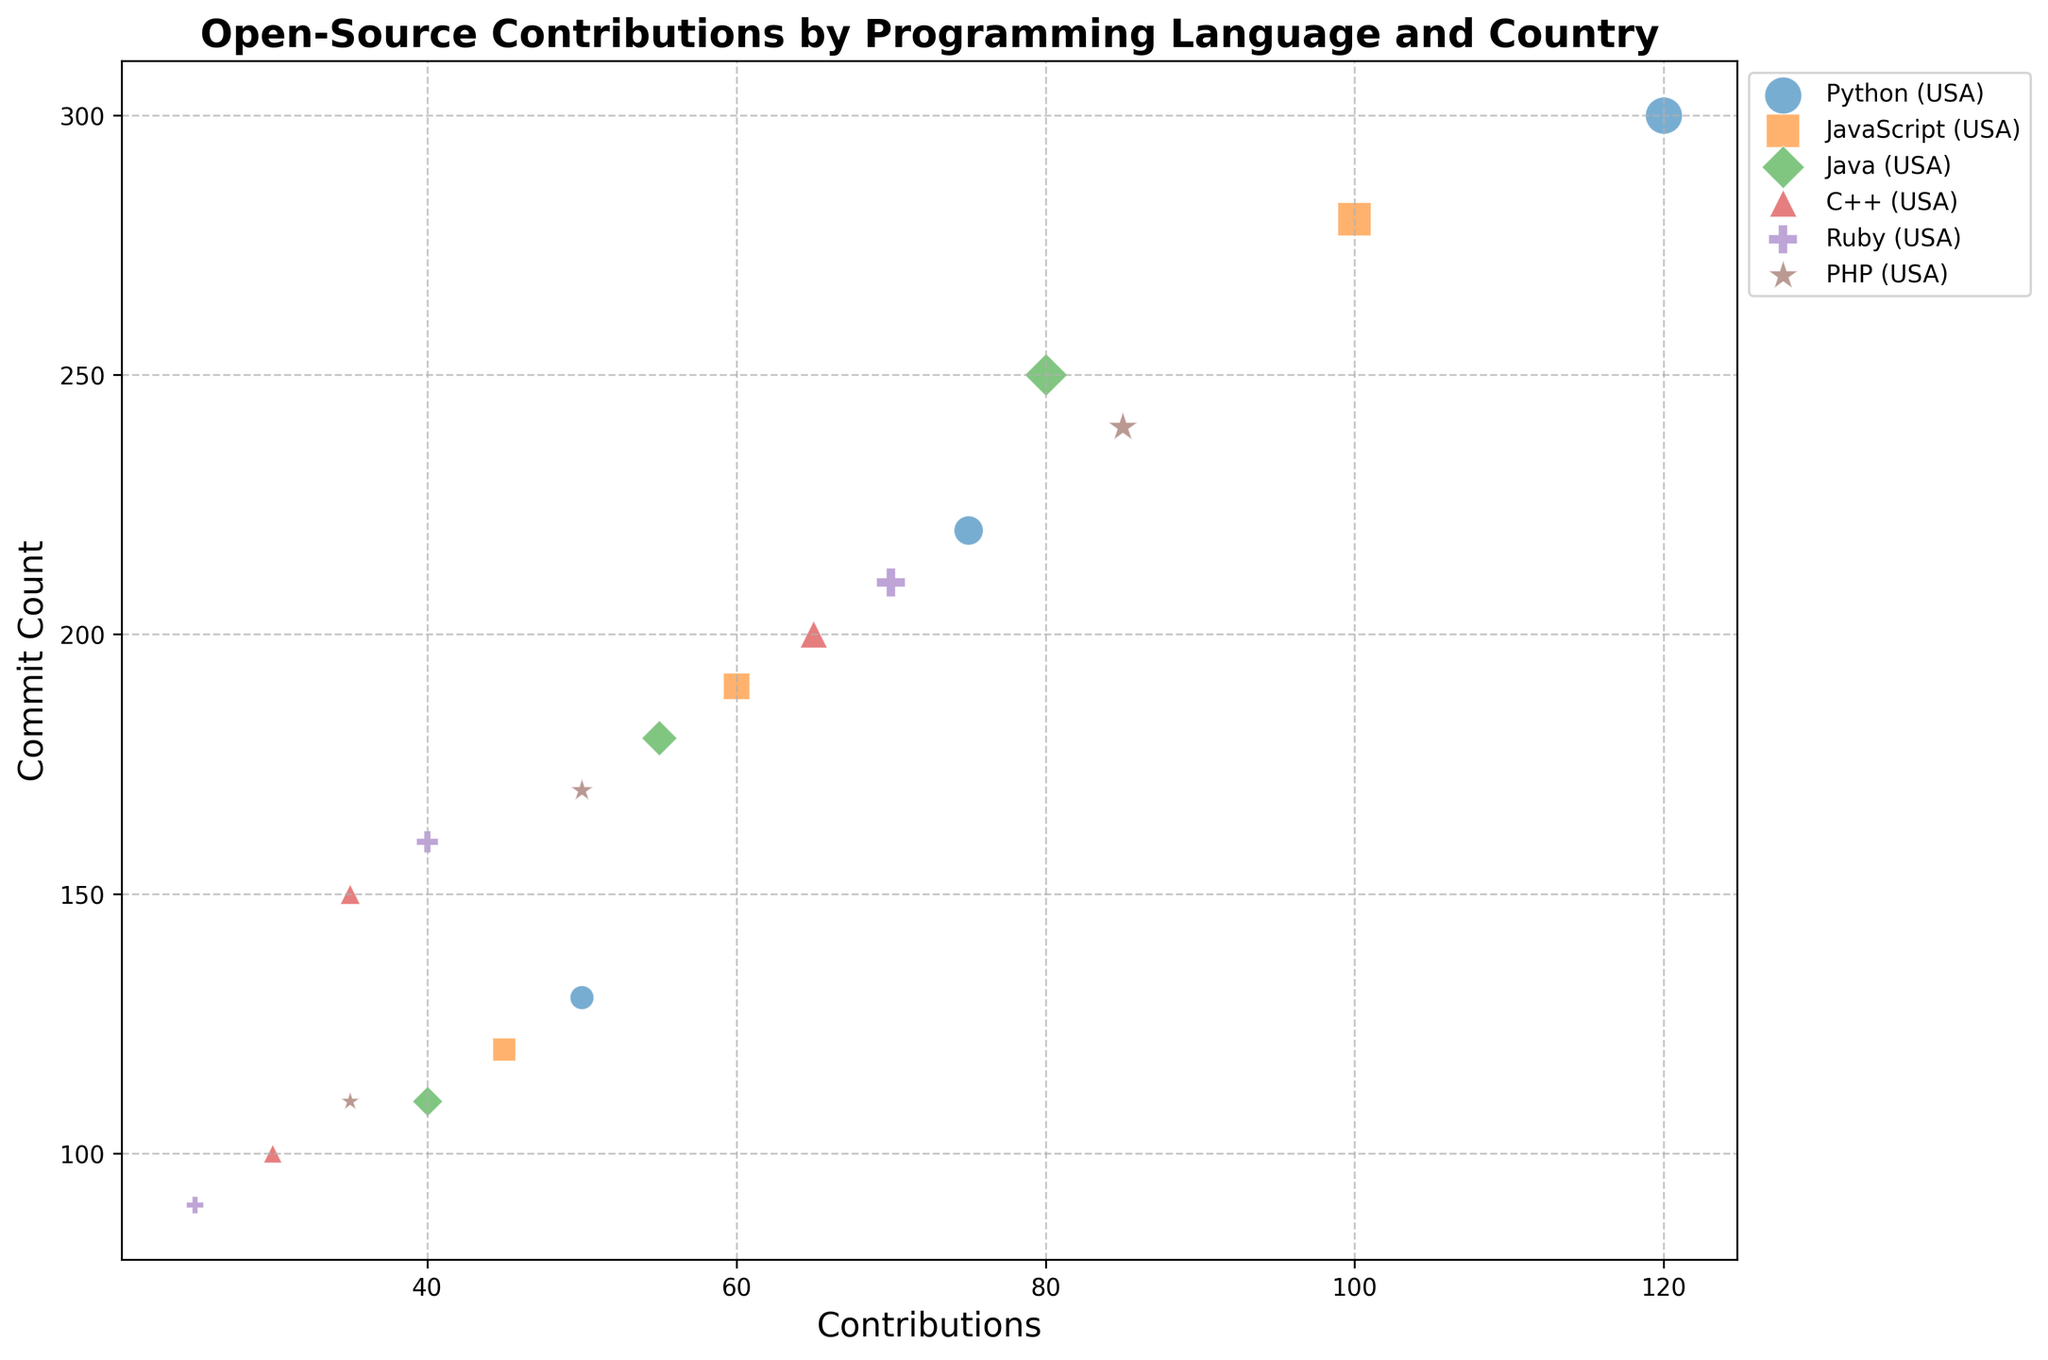Which country has the highest contributions for Python? By examining the bubbles labeled Python, the largest bubble in terms of contributions for Python is associated with the USA. The size indicates the number of contributions, and the USA bubble is the largest in comparison to India and Germany.
Answer: USA Which programming language shows the lowest number of contributions from Germany? Among the bubbles representing Germany, the smallest bubble in contributions corresponds to Ruby, with just 25 contributions.
Answer: Ruby Which country contributed more to JavaScript, India or Germany? By comparing the bubbles for JavaScript from India and Germany, it's evident that India has a larger bubble than Germany, indicating higher contributions.
Answer: India Which programming language has the highest commit count from the USA? The bubbles for each programming language from the USA show that Python has the highest commit count with 300 commits, as indicated by the bubble size and its height on the commit count axis.
Answer: Python What's the total number of contributions to Java across all countries? To find the total, sum the contributions from the USA, India, and Germany for Java: 80 (USA) + 55 (India) + 40 (Germany) = 175.
Answer: 175 Which programming language has the most uniform contribution sizes across all three countries? Analyzing the size of bubbles for each programming language across all countries, C++ seems the most uniform, as the bubbles differ less in size compared to other languages.
Answer: C++ Between USA and India, which has a higher average commit count for their top contributing programming language? First, identify the top contributing language for the USA (Python with 300 commits) and India (Python with 220 commits). Then compare the commit counts: 300 (USA) is higher than 220 (India).
Answer: USA For which programming language do contributors from India and Germany have the closest number of contributions? By examining the size of the bubbles for all programming languages between India and Germany, contributions for C++ are the closest, with 35 from India and 30 from Germany.
Answer: C++ How many contributions separate the highest contributing country from the lowest for PHP? For PHP, the highest contributing country is the USA with 85 contributions and the lowest is Germany with 35. The difference is 85 - 35 = 50.
Answer: 50 Which country has the highest bubble diversity in terms of programming languages' contributions? By counting distinct bubble sizes for each country, the USA shows the most diversity with larger differences in contributions across all programming languages.
Answer: USA 